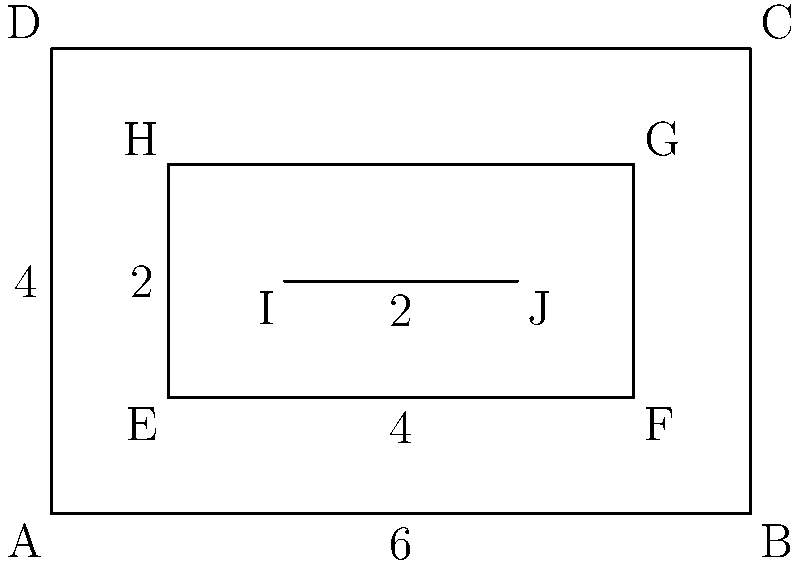You are designing a multi-tiered wooden box for plants. The outer rectangle ABCD represents the base of the box, while EFGH represents the first tier, and IJ represents the second tier. Given that rectangle ABCD has dimensions 6 units by 4 units, and rectangles EFGH and IJKL (where K and L are not shown) are congruent, what is the area of rectangle IJKL? Let's approach this step-by-step:

1) First, we need to find the dimensions of rectangle EFGH.
   - The width of EFGH is 4 units (6 - 1 - 1 = 4)
   - The height of EFGH is 2 units (4 - 1 - 1 = 2)

2) Now, we know that IJKL is congruent to EFGH. This means they have the same dimensions.

3) To find the area of IJKL, we need to multiply its width by its height:
   $$ \text{Area of IJKL} = \text{width} \times \text{height} = 4 \times 2 = 8 $$

4) Therefore, the area of rectangle IJKL is 8 square units.
Answer: 8 square units 